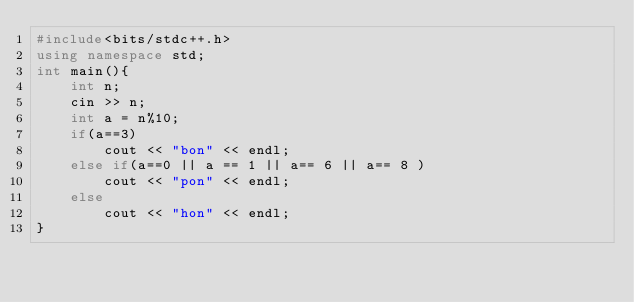Convert code to text. <code><loc_0><loc_0><loc_500><loc_500><_C++_>#include<bits/stdc++.h>
using namespace std;
int main(){
	int n;
	cin >> n;
	int a = n%10;
	if(a==3)
		cout << "bon" << endl;
	else if(a==0 || a == 1 || a== 6 || a== 8 )
		cout << "pon" << endl;
	else
		cout << "hon" << endl;	
}</code> 